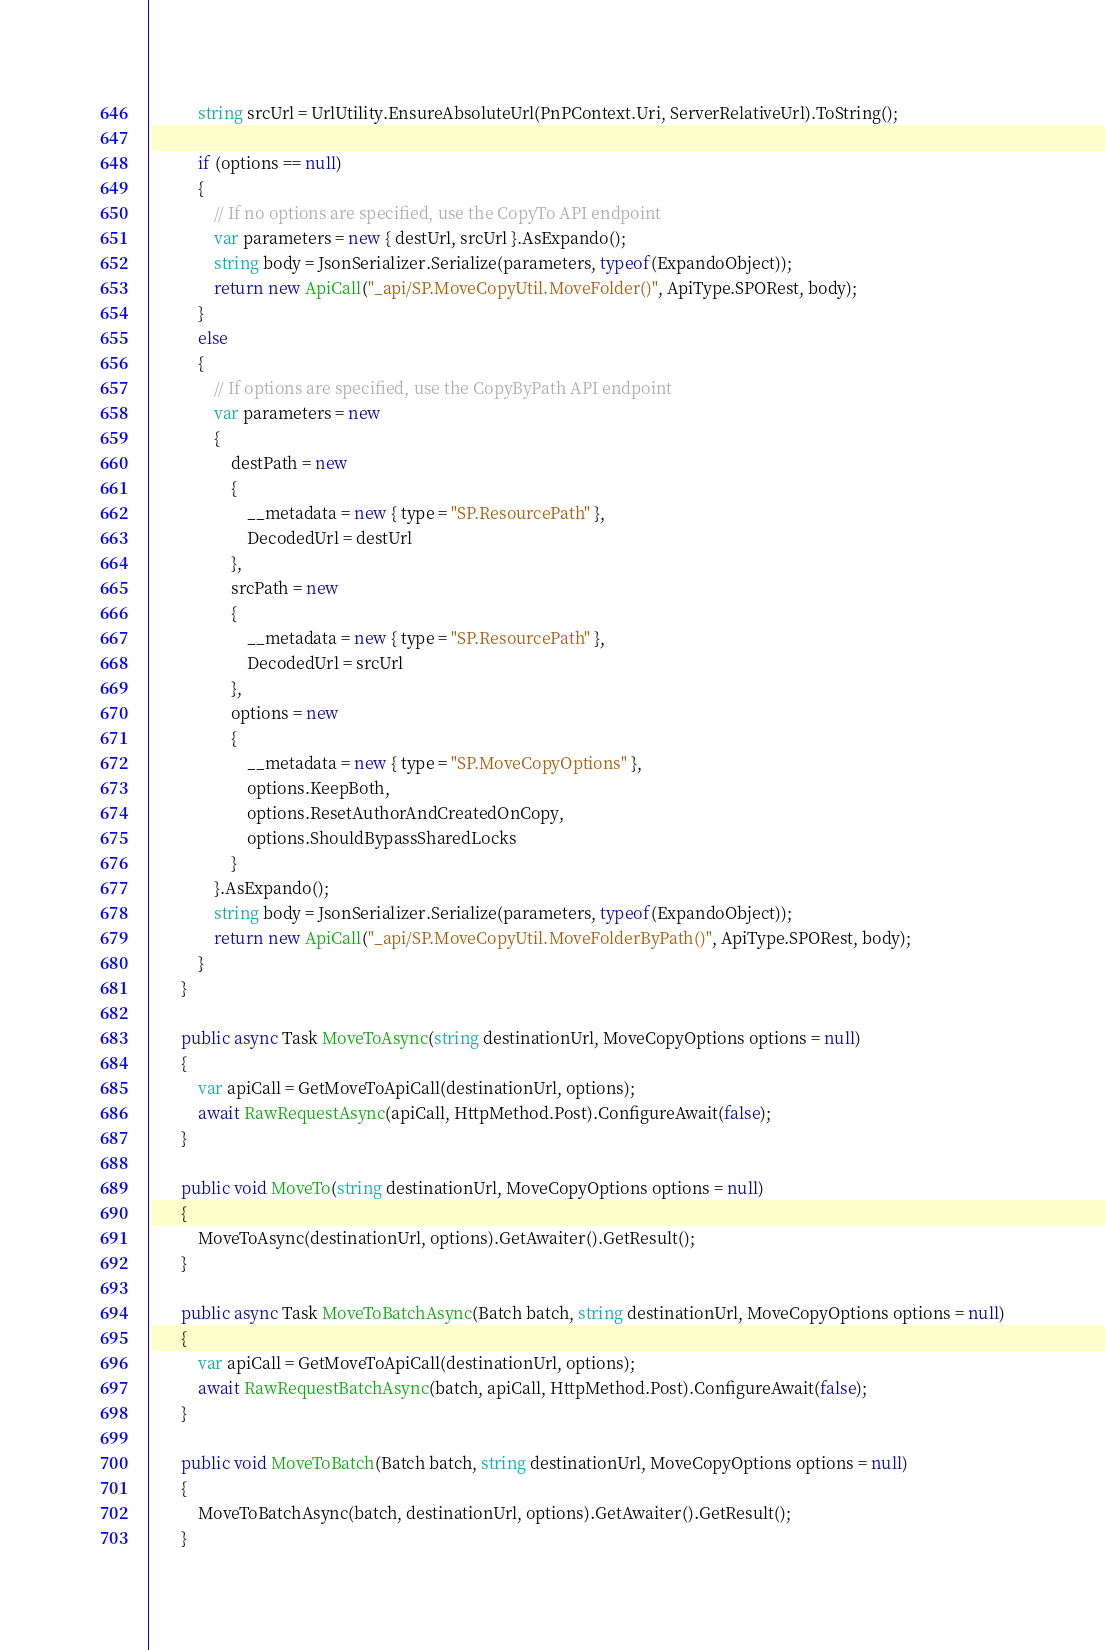Convert code to text. <code><loc_0><loc_0><loc_500><loc_500><_C#_>            string srcUrl = UrlUtility.EnsureAbsoluteUrl(PnPContext.Uri, ServerRelativeUrl).ToString();

            if (options == null)
            {
                // If no options are specified, use the CopyTo API endpoint
                var parameters = new { destUrl, srcUrl }.AsExpando();
                string body = JsonSerializer.Serialize(parameters, typeof(ExpandoObject));
                return new ApiCall("_api/SP.MoveCopyUtil.MoveFolder()", ApiType.SPORest, body);
            }
            else
            {
                // If options are specified, use the CopyByPath API endpoint
                var parameters = new
                {
                    destPath = new
                    {
                        __metadata = new { type = "SP.ResourcePath" },
                        DecodedUrl = destUrl
                    },
                    srcPath = new
                    {
                        __metadata = new { type = "SP.ResourcePath" },
                        DecodedUrl = srcUrl
                    },
                    options = new
                    {
                        __metadata = new { type = "SP.MoveCopyOptions" },
                        options.KeepBoth,
                        options.ResetAuthorAndCreatedOnCopy,
                        options.ShouldBypassSharedLocks
                    }
                }.AsExpando();
                string body = JsonSerializer.Serialize(parameters, typeof(ExpandoObject));
                return new ApiCall("_api/SP.MoveCopyUtil.MoveFolderByPath()", ApiType.SPORest, body);
            }
        }

        public async Task MoveToAsync(string destinationUrl, MoveCopyOptions options = null)
        {
            var apiCall = GetMoveToApiCall(destinationUrl, options);
            await RawRequestAsync(apiCall, HttpMethod.Post).ConfigureAwait(false);
        }

        public void MoveTo(string destinationUrl, MoveCopyOptions options = null)
        {
            MoveToAsync(destinationUrl, options).GetAwaiter().GetResult();
        }

        public async Task MoveToBatchAsync(Batch batch, string destinationUrl, MoveCopyOptions options = null)
        {
            var apiCall = GetMoveToApiCall(destinationUrl, options);
            await RawRequestBatchAsync(batch, apiCall, HttpMethod.Post).ConfigureAwait(false);
        }

        public void MoveToBatch(Batch batch, string destinationUrl, MoveCopyOptions options = null)
        {
            MoveToBatchAsync(batch, destinationUrl, options).GetAwaiter().GetResult();
        }
</code> 